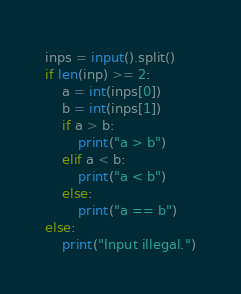Convert code to text. <code><loc_0><loc_0><loc_500><loc_500><_Python_>inps = input().split()
if len(inp) >= 2:
    a = int(inps[0])
    b = int(inps[1])
    if a > b:
        print("a > b")
    elif a < b:
        print("a < b")
    else:
        print("a == b")
else:
    print("Input illegal.")</code> 